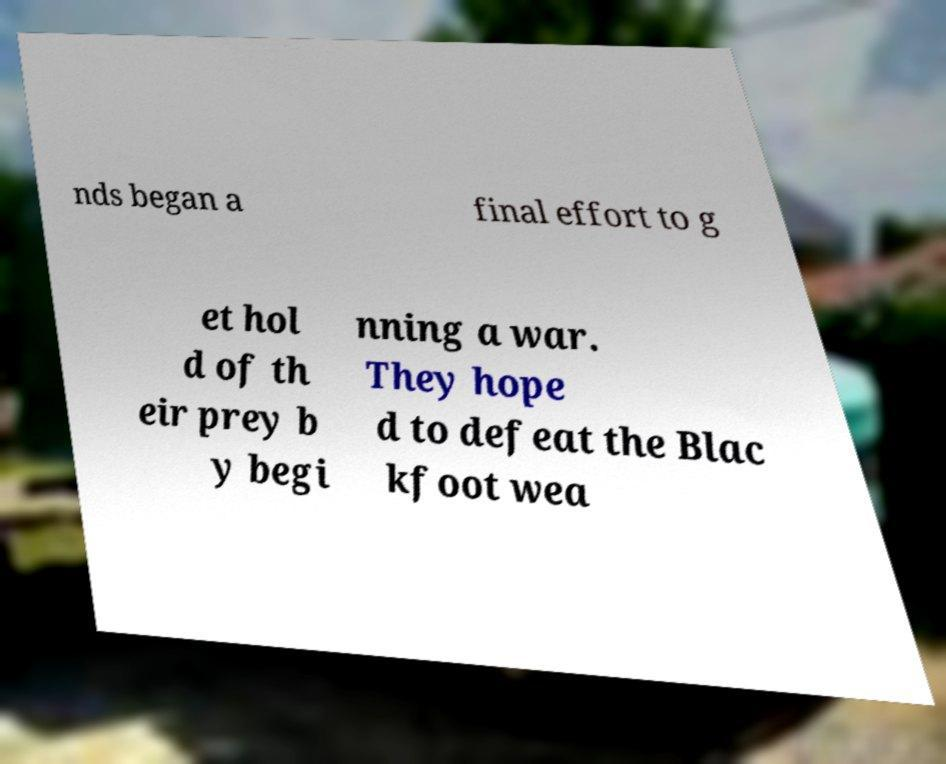There's text embedded in this image that I need extracted. Can you transcribe it verbatim? nds began a final effort to g et hol d of th eir prey b y begi nning a war. They hope d to defeat the Blac kfoot wea 